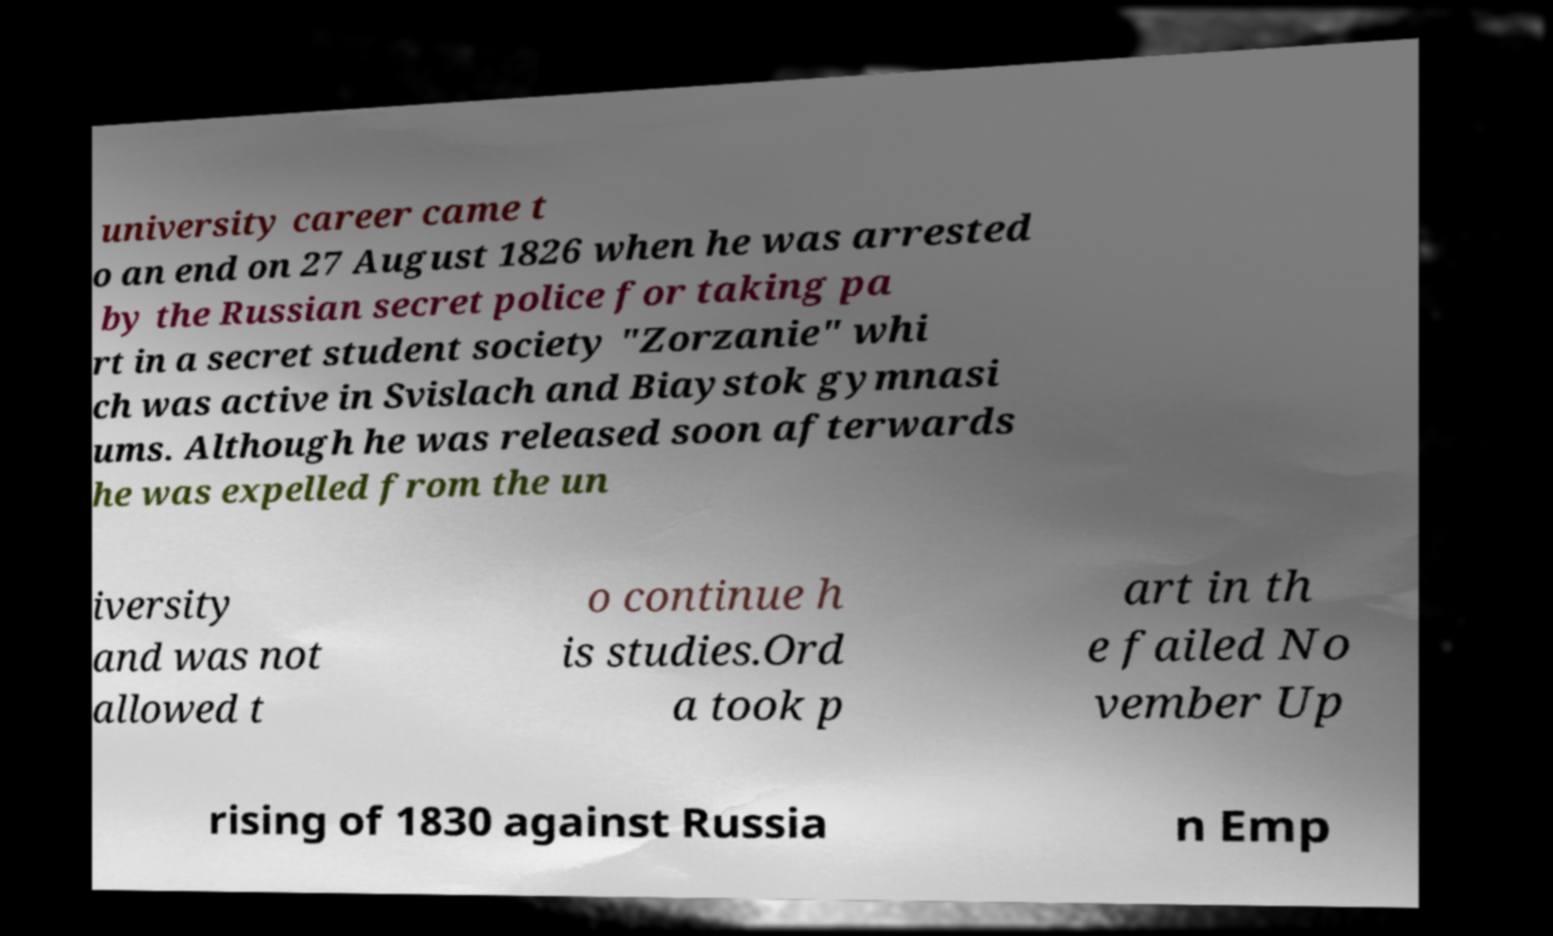There's text embedded in this image that I need extracted. Can you transcribe it verbatim? university career came t o an end on 27 August 1826 when he was arrested by the Russian secret police for taking pa rt in a secret student society "Zorzanie" whi ch was active in Svislach and Biaystok gymnasi ums. Although he was released soon afterwards he was expelled from the un iversity and was not allowed t o continue h is studies.Ord a took p art in th e failed No vember Up rising of 1830 against Russia n Emp 